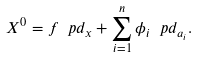<formula> <loc_0><loc_0><loc_500><loc_500>X ^ { 0 } = f \ p d _ { x } + \sum _ { i = 1 } ^ { n } \phi _ { i } \ p d _ { a _ { i } } .</formula> 